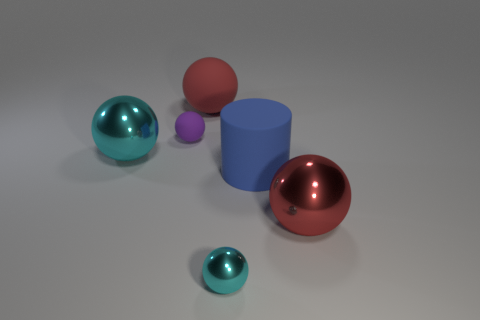The shiny object that is the same color as the large rubber ball is what shape?
Ensure brevity in your answer.  Sphere. The shiny ball that is the same color as the tiny metal thing is what size?
Your response must be concise. Large. There is a big metallic ball that is on the right side of the purple rubber sphere; how many small cyan objects are behind it?
Offer a terse response. 0. Is the material of the big red sphere that is on the right side of the small metal object the same as the large cyan thing?
Provide a short and direct response. Yes. Are there any other things that are made of the same material as the blue cylinder?
Make the answer very short. Yes. What is the size of the cyan thing that is on the left side of the large red thing that is to the left of the red shiny object?
Keep it short and to the point. Large. How big is the cyan ball that is left of the red thing that is behind the large shiny ball right of the tiny purple rubber sphere?
Your response must be concise. Large. Is the shape of the big red thing in front of the big blue rubber cylinder the same as the big red thing that is behind the large blue rubber cylinder?
Provide a short and direct response. Yes. What number of other things are the same color as the tiny shiny thing?
Offer a very short reply. 1. There is a cyan object right of the purple sphere; is it the same size as the cylinder?
Offer a very short reply. No. 